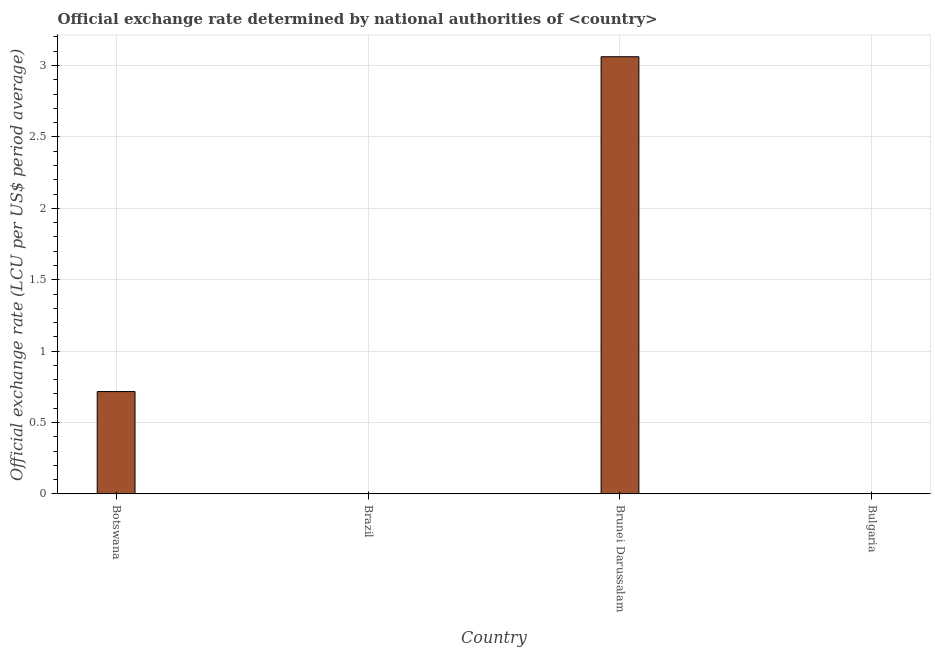Does the graph contain any zero values?
Provide a succinct answer. No. Does the graph contain grids?
Make the answer very short. Yes. What is the title of the graph?
Offer a very short reply. Official exchange rate determined by national authorities of <country>. What is the label or title of the Y-axis?
Give a very brief answer. Official exchange rate (LCU per US$ period average). What is the official exchange rate in Brazil?
Provide a succinct answer. 9.60713051097307e-13. Across all countries, what is the maximum official exchange rate?
Offer a very short reply. 3.06. Across all countries, what is the minimum official exchange rate?
Your response must be concise. 9.60713051097307e-13. In which country was the official exchange rate maximum?
Offer a very short reply. Brunei Darussalam. What is the sum of the official exchange rate?
Your answer should be very brief. 3.78. What is the difference between the official exchange rate in Botswana and Brazil?
Keep it short and to the point. 0.72. What is the average official exchange rate per country?
Your answer should be compact. 0.94. What is the median official exchange rate?
Your answer should be compact. 0.36. In how many countries, is the official exchange rate greater than 3 ?
Provide a short and direct response. 1. What is the ratio of the official exchange rate in Botswana to that in Brunei Darussalam?
Ensure brevity in your answer.  0.23. Is the difference between the official exchange rate in Botswana and Brunei Darussalam greater than the difference between any two countries?
Ensure brevity in your answer.  No. What is the difference between the highest and the second highest official exchange rate?
Offer a very short reply. 2.34. Is the sum of the official exchange rate in Brunei Darussalam and Bulgaria greater than the maximum official exchange rate across all countries?
Keep it short and to the point. Yes. What is the difference between the highest and the lowest official exchange rate?
Give a very brief answer. 3.06. How many countries are there in the graph?
Offer a terse response. 4. What is the Official exchange rate (LCU per US$ period average) in Botswana?
Keep it short and to the point. 0.72. What is the Official exchange rate (LCU per US$ period average) in Brazil?
Your answer should be very brief. 9.60713051097307e-13. What is the Official exchange rate (LCU per US$ period average) in Brunei Darussalam?
Your response must be concise. 3.06. What is the Official exchange rate (LCU per US$ period average) of Bulgaria?
Ensure brevity in your answer.  0. What is the difference between the Official exchange rate (LCU per US$ period average) in Botswana and Brazil?
Make the answer very short. 0.72. What is the difference between the Official exchange rate (LCU per US$ period average) in Botswana and Brunei Darussalam?
Give a very brief answer. -2.34. What is the difference between the Official exchange rate (LCU per US$ period average) in Botswana and Bulgaria?
Offer a terse response. 0.72. What is the difference between the Official exchange rate (LCU per US$ period average) in Brazil and Brunei Darussalam?
Give a very brief answer. -3.06. What is the difference between the Official exchange rate (LCU per US$ period average) in Brazil and Bulgaria?
Offer a very short reply. -0. What is the difference between the Official exchange rate (LCU per US$ period average) in Brunei Darussalam and Bulgaria?
Your answer should be very brief. 3.06. What is the ratio of the Official exchange rate (LCU per US$ period average) in Botswana to that in Brazil?
Offer a terse response. 7.46e+11. What is the ratio of the Official exchange rate (LCU per US$ period average) in Botswana to that in Brunei Darussalam?
Offer a very short reply. 0.23. What is the ratio of the Official exchange rate (LCU per US$ period average) in Botswana to that in Bulgaria?
Give a very brief answer. 612.81. What is the ratio of the Official exchange rate (LCU per US$ period average) in Brazil to that in Brunei Darussalam?
Provide a short and direct response. 0. What is the ratio of the Official exchange rate (LCU per US$ period average) in Brunei Darussalam to that in Bulgaria?
Provide a succinct answer. 2616.43. 